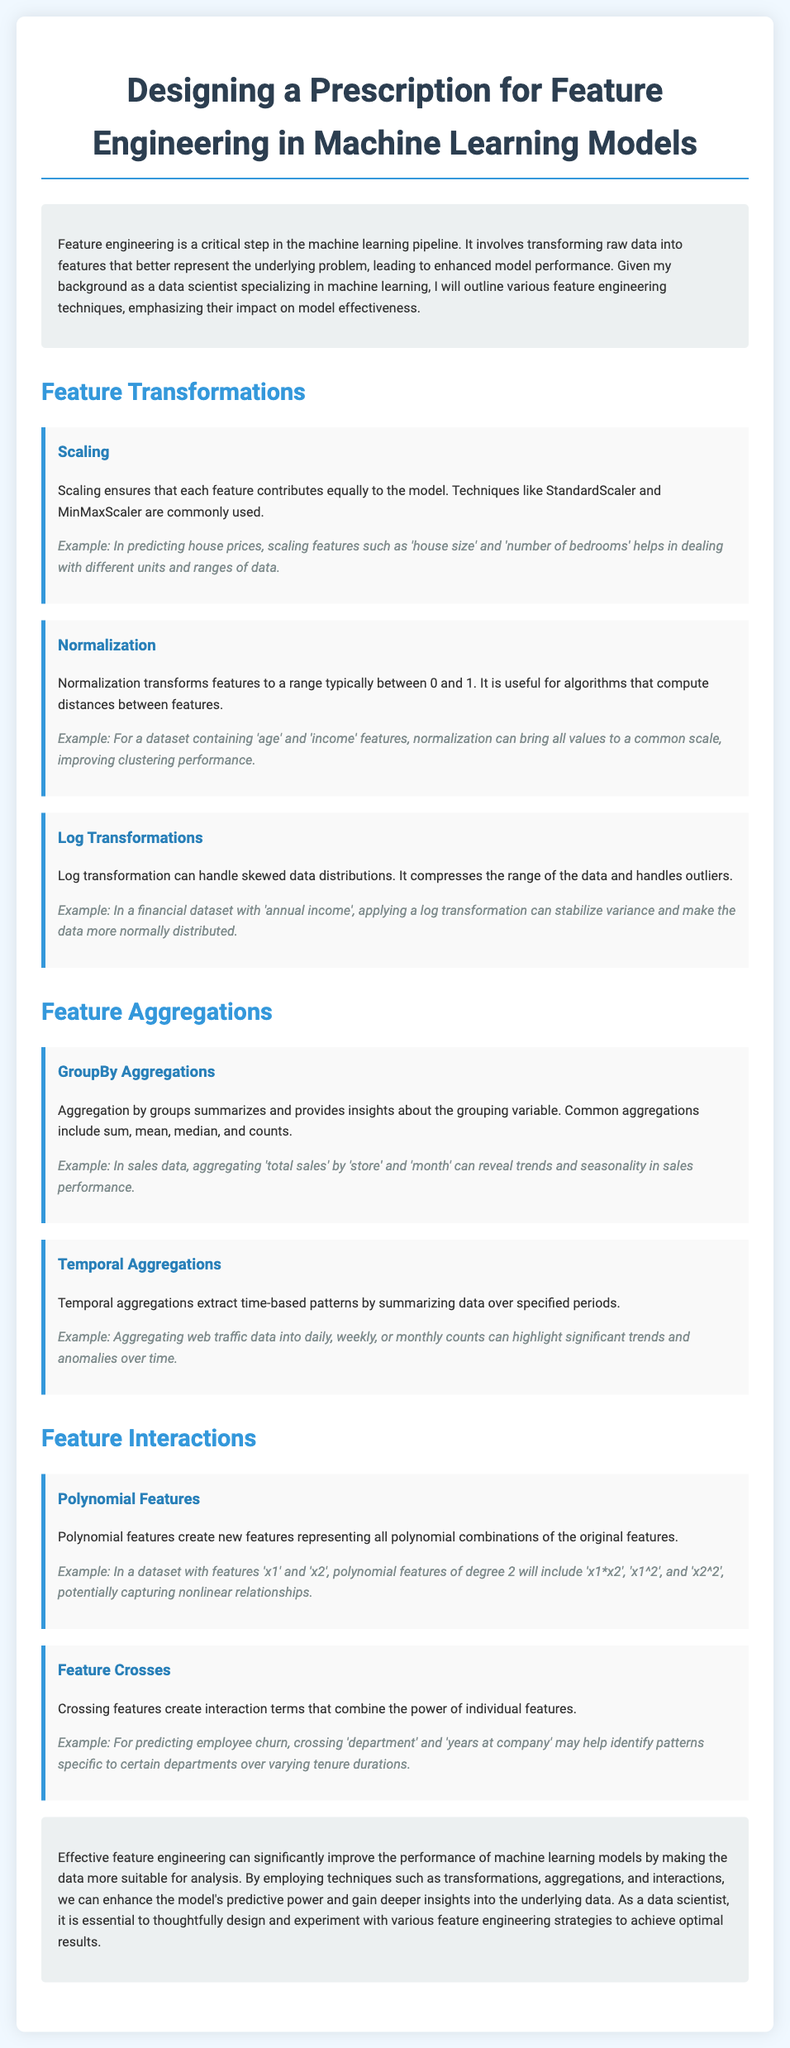What is the title of the document? The title is stated at the top of the document as the main heading.
Answer: Designing a Prescription for Feature Engineering in Machine Learning Models What is one common scaling technique mentioned? The document lists scaling techniques such as StandardScaler and MinMaxScaler.
Answer: StandardScaler What is the primary benefit of normalization? The benefit of normalization is described in relation to algorithms that compute distances between features.
Answer: Improved clustering performance What is one example of temporal aggregation? The document provides daily, weekly, or monthly counts as a specific example of temporal aggregations.
Answer: Daily, weekly, or monthly counts What technique creates new features representing polynomial combinations? The document explicitly mentions a technique that does this.
Answer: Polynomial features What is the primary focus of the introduction section? The introduction section outlines the significance and role of feature engineering in the machine learning pipeline.
Answer: Feature engineering importance What type of data transformation can handle skewed distributions? The document identifies a specific transformation that addresses skewed data.
Answer: Log transformations What is the purpose of feature crosses according to the document? The document explains that feature crosses create interaction terms that combine the power of individual features.
Answer: To create interaction terms What is emphasized in the conclusion of the document? The conclusion summarizes the importance of effective feature engineering on model performance.
Answer: Importance of feature engineering 